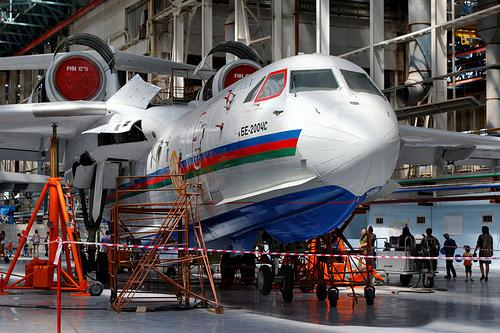Discuss the scene in the image from the perspective of a visitor. As a visitor, I see an airplane on display surrounded by a red and white striped rope, with people admiring it and some accessories placed nearby. Describe the activity taking place in the image focusing on the people. People are observing and walking around the airplane on display, while a child holds a blue balloon. Write a short overview of the setting portrayed in the image. The setting is an airplane exhibit, with the plane surrounded by a striped rope, and people walking around admiring the display. Provide a short description of the primary focus in the image. An airplane is on display with people admiring it, surrounded by a red and white striped rope. Write a brief description of the plane's appearance in the image. The plane has a white body with red, blue, and green stripes, and a blue bottom with black numbers and letters. Describe the different colored stripes on the airplane in the image. There are red, blue, and green stripes running along the side of the white airplane. Explain the role of the accessories surrounding the plane in the image. There is a ladder, cart, and portable staircase placed near the plane, indicating maintenance or pre-flight preparations. Briefly describe the colors and noticeable patterns in the image. The image has white, blue, red, and green colors with striped patterns like the rope around the airplane and lines on its side. Mention the most interesting detail of the image. A child is standing near the airplane, holding a blue balloon. Mention the most notable elements in the image. An airplane, the red and white striped rope, people observing, and various accessories like a ladder and cart. 